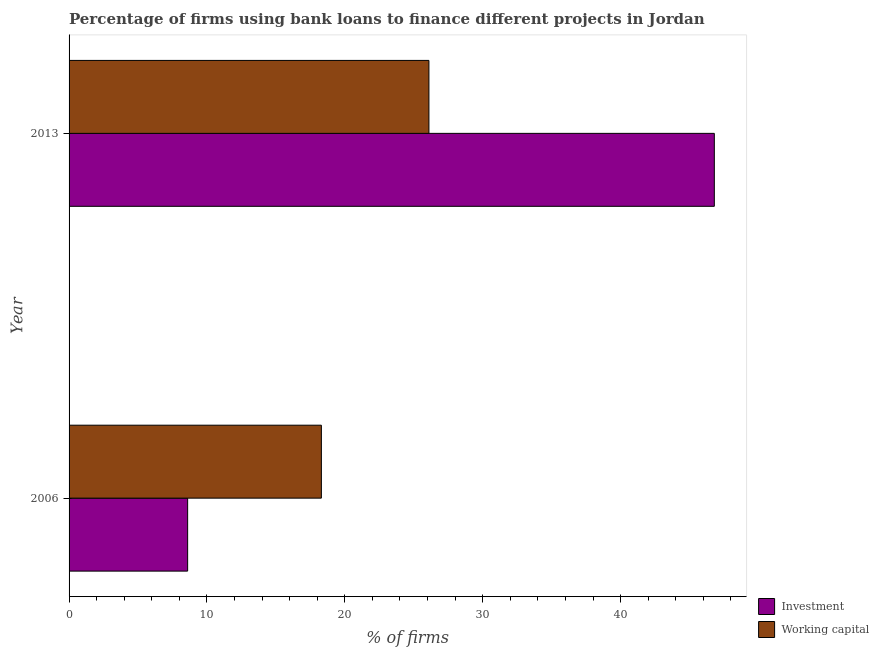Are the number of bars per tick equal to the number of legend labels?
Make the answer very short. Yes. Are the number of bars on each tick of the Y-axis equal?
Your answer should be very brief. Yes. How many bars are there on the 1st tick from the top?
Keep it short and to the point. 2. How many bars are there on the 2nd tick from the bottom?
Provide a short and direct response. 2. Across all years, what is the maximum percentage of firms using banks to finance investment?
Provide a short and direct response. 46.8. Across all years, what is the minimum percentage of firms using banks to finance investment?
Provide a succinct answer. 8.6. In which year was the percentage of firms using banks to finance working capital minimum?
Give a very brief answer. 2006. What is the total percentage of firms using banks to finance working capital in the graph?
Your answer should be very brief. 44.4. What is the difference between the percentage of firms using banks to finance investment in 2006 and that in 2013?
Your answer should be very brief. -38.2. What is the difference between the percentage of firms using banks to finance investment in 2006 and the percentage of firms using banks to finance working capital in 2013?
Make the answer very short. -17.5. In how many years, is the percentage of firms using banks to finance working capital greater than 44 %?
Your response must be concise. 0. What is the ratio of the percentage of firms using banks to finance investment in 2006 to that in 2013?
Keep it short and to the point. 0.18. In how many years, is the percentage of firms using banks to finance working capital greater than the average percentage of firms using banks to finance working capital taken over all years?
Ensure brevity in your answer.  1. What does the 2nd bar from the top in 2006 represents?
Offer a terse response. Investment. What does the 1st bar from the bottom in 2013 represents?
Keep it short and to the point. Investment. How many bars are there?
Your answer should be compact. 4. How many years are there in the graph?
Ensure brevity in your answer.  2. What is the difference between two consecutive major ticks on the X-axis?
Offer a terse response. 10. Are the values on the major ticks of X-axis written in scientific E-notation?
Make the answer very short. No. Does the graph contain any zero values?
Keep it short and to the point. No. Where does the legend appear in the graph?
Your response must be concise. Bottom right. How many legend labels are there?
Provide a short and direct response. 2. How are the legend labels stacked?
Make the answer very short. Vertical. What is the title of the graph?
Provide a succinct answer. Percentage of firms using bank loans to finance different projects in Jordan. What is the label or title of the X-axis?
Offer a terse response. % of firms. What is the % of firms of Investment in 2013?
Provide a succinct answer. 46.8. What is the % of firms in Working capital in 2013?
Ensure brevity in your answer.  26.1. Across all years, what is the maximum % of firms of Investment?
Your answer should be compact. 46.8. Across all years, what is the maximum % of firms in Working capital?
Your answer should be compact. 26.1. What is the total % of firms of Investment in the graph?
Offer a terse response. 55.4. What is the total % of firms of Working capital in the graph?
Provide a short and direct response. 44.4. What is the difference between the % of firms of Investment in 2006 and that in 2013?
Your answer should be compact. -38.2. What is the difference between the % of firms of Investment in 2006 and the % of firms of Working capital in 2013?
Keep it short and to the point. -17.5. What is the average % of firms of Investment per year?
Keep it short and to the point. 27.7. In the year 2013, what is the difference between the % of firms of Investment and % of firms of Working capital?
Offer a very short reply. 20.7. What is the ratio of the % of firms in Investment in 2006 to that in 2013?
Ensure brevity in your answer.  0.18. What is the ratio of the % of firms in Working capital in 2006 to that in 2013?
Offer a very short reply. 0.7. What is the difference between the highest and the second highest % of firms of Investment?
Offer a terse response. 38.2. What is the difference between the highest and the lowest % of firms of Investment?
Make the answer very short. 38.2. What is the difference between the highest and the lowest % of firms of Working capital?
Give a very brief answer. 7.8. 